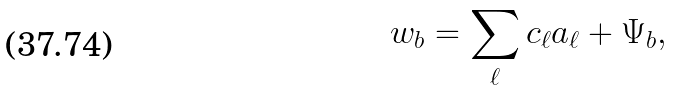<formula> <loc_0><loc_0><loc_500><loc_500>w _ { b } = \sum _ { \ell } c _ { \ell } a _ { \ell } + \Psi _ { b } ,</formula> 